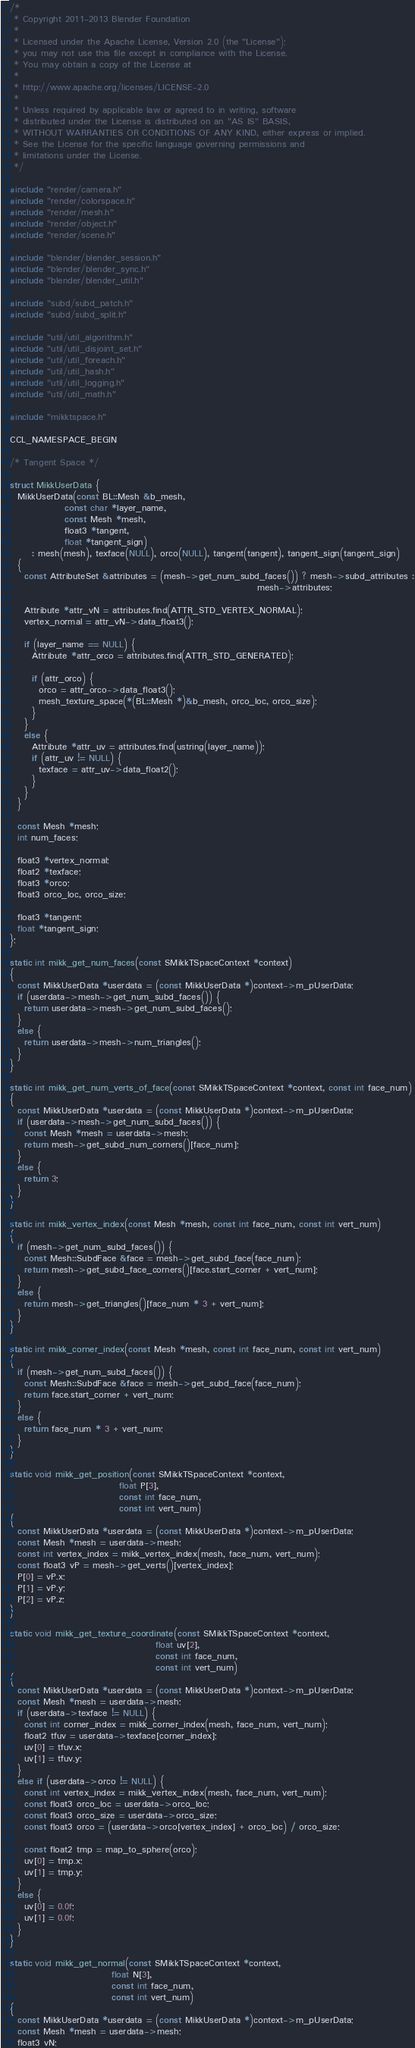Convert code to text. <code><loc_0><loc_0><loc_500><loc_500><_C++_>/*
 * Copyright 2011-2013 Blender Foundation
 *
 * Licensed under the Apache License, Version 2.0 (the "License");
 * you may not use this file except in compliance with the License.
 * You may obtain a copy of the License at
 *
 * http://www.apache.org/licenses/LICENSE-2.0
 *
 * Unless required by applicable law or agreed to in writing, software
 * distributed under the License is distributed on an "AS IS" BASIS,
 * WITHOUT WARRANTIES OR CONDITIONS OF ANY KIND, either express or implied.
 * See the License for the specific language governing permissions and
 * limitations under the License.
 */

#include "render/camera.h"
#include "render/colorspace.h"
#include "render/mesh.h"
#include "render/object.h"
#include "render/scene.h"

#include "blender/blender_session.h"
#include "blender/blender_sync.h"
#include "blender/blender_util.h"

#include "subd/subd_patch.h"
#include "subd/subd_split.h"

#include "util/util_algorithm.h"
#include "util/util_disjoint_set.h"
#include "util/util_foreach.h"
#include "util/util_hash.h"
#include "util/util_logging.h"
#include "util/util_math.h"

#include "mikktspace.h"

CCL_NAMESPACE_BEGIN

/* Tangent Space */

struct MikkUserData {
  MikkUserData(const BL::Mesh &b_mesh,
               const char *layer_name,
               const Mesh *mesh,
               float3 *tangent,
               float *tangent_sign)
      : mesh(mesh), texface(NULL), orco(NULL), tangent(tangent), tangent_sign(tangent_sign)
  {
    const AttributeSet &attributes = (mesh->get_num_subd_faces()) ? mesh->subd_attributes :
                                                                    mesh->attributes;

    Attribute *attr_vN = attributes.find(ATTR_STD_VERTEX_NORMAL);
    vertex_normal = attr_vN->data_float3();

    if (layer_name == NULL) {
      Attribute *attr_orco = attributes.find(ATTR_STD_GENERATED);

      if (attr_orco) {
        orco = attr_orco->data_float3();
        mesh_texture_space(*(BL::Mesh *)&b_mesh, orco_loc, orco_size);
      }
    }
    else {
      Attribute *attr_uv = attributes.find(ustring(layer_name));
      if (attr_uv != NULL) {
        texface = attr_uv->data_float2();
      }
    }
  }

  const Mesh *mesh;
  int num_faces;

  float3 *vertex_normal;
  float2 *texface;
  float3 *orco;
  float3 orco_loc, orco_size;

  float3 *tangent;
  float *tangent_sign;
};

static int mikk_get_num_faces(const SMikkTSpaceContext *context)
{
  const MikkUserData *userdata = (const MikkUserData *)context->m_pUserData;
  if (userdata->mesh->get_num_subd_faces()) {
    return userdata->mesh->get_num_subd_faces();
  }
  else {
    return userdata->mesh->num_triangles();
  }
}

static int mikk_get_num_verts_of_face(const SMikkTSpaceContext *context, const int face_num)
{
  const MikkUserData *userdata = (const MikkUserData *)context->m_pUserData;
  if (userdata->mesh->get_num_subd_faces()) {
    const Mesh *mesh = userdata->mesh;
    return mesh->get_subd_num_corners()[face_num];
  }
  else {
    return 3;
  }
}

static int mikk_vertex_index(const Mesh *mesh, const int face_num, const int vert_num)
{
  if (mesh->get_num_subd_faces()) {
    const Mesh::SubdFace &face = mesh->get_subd_face(face_num);
    return mesh->get_subd_face_corners()[face.start_corner + vert_num];
  }
  else {
    return mesh->get_triangles()[face_num * 3 + vert_num];
  }
}

static int mikk_corner_index(const Mesh *mesh, const int face_num, const int vert_num)
{
  if (mesh->get_num_subd_faces()) {
    const Mesh::SubdFace &face = mesh->get_subd_face(face_num);
    return face.start_corner + vert_num;
  }
  else {
    return face_num * 3 + vert_num;
  }
}

static void mikk_get_position(const SMikkTSpaceContext *context,
                              float P[3],
                              const int face_num,
                              const int vert_num)
{
  const MikkUserData *userdata = (const MikkUserData *)context->m_pUserData;
  const Mesh *mesh = userdata->mesh;
  const int vertex_index = mikk_vertex_index(mesh, face_num, vert_num);
  const float3 vP = mesh->get_verts()[vertex_index];
  P[0] = vP.x;
  P[1] = vP.y;
  P[2] = vP.z;
}

static void mikk_get_texture_coordinate(const SMikkTSpaceContext *context,
                                        float uv[2],
                                        const int face_num,
                                        const int vert_num)
{
  const MikkUserData *userdata = (const MikkUserData *)context->m_pUserData;
  const Mesh *mesh = userdata->mesh;
  if (userdata->texface != NULL) {
    const int corner_index = mikk_corner_index(mesh, face_num, vert_num);
    float2 tfuv = userdata->texface[corner_index];
    uv[0] = tfuv.x;
    uv[1] = tfuv.y;
  }
  else if (userdata->orco != NULL) {
    const int vertex_index = mikk_vertex_index(mesh, face_num, vert_num);
    const float3 orco_loc = userdata->orco_loc;
    const float3 orco_size = userdata->orco_size;
    const float3 orco = (userdata->orco[vertex_index] + orco_loc) / orco_size;

    const float2 tmp = map_to_sphere(orco);
    uv[0] = tmp.x;
    uv[1] = tmp.y;
  }
  else {
    uv[0] = 0.0f;
    uv[1] = 0.0f;
  }
}

static void mikk_get_normal(const SMikkTSpaceContext *context,
                            float N[3],
                            const int face_num,
                            const int vert_num)
{
  const MikkUserData *userdata = (const MikkUserData *)context->m_pUserData;
  const Mesh *mesh = userdata->mesh;
  float3 vN;</code> 